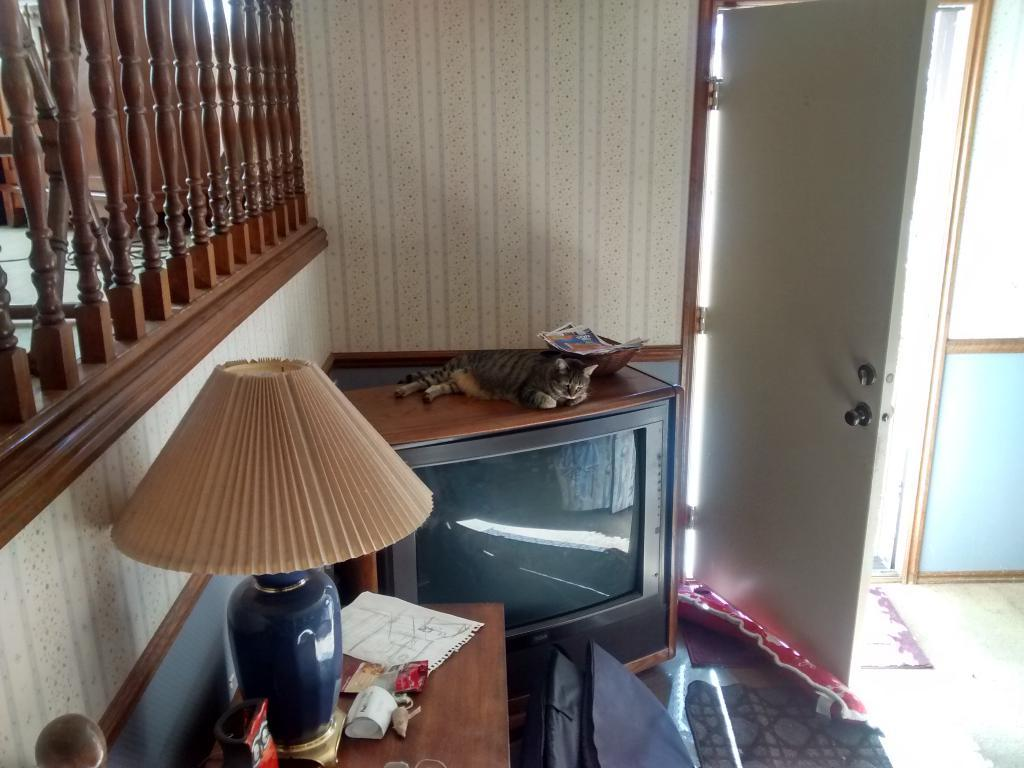What electronic device is visible in the image? There is a television in the image. What architectural feature can be seen in the image? There is a railing and a door in the image. What type of lighting is present in the image? There is a lamp on the table in the image. What is the cat doing in the image? The cat is on the television in the image. What is placed near the door in the image? There is a door mat in the image. What other items are on the table in the image? There are additional items on the table in the image. Can you see a mountain in the background of the image? There is no mountain visible in the image. Is there a volleyball being played in the image? There is no volleyball or any indication of a game being played in the image. 